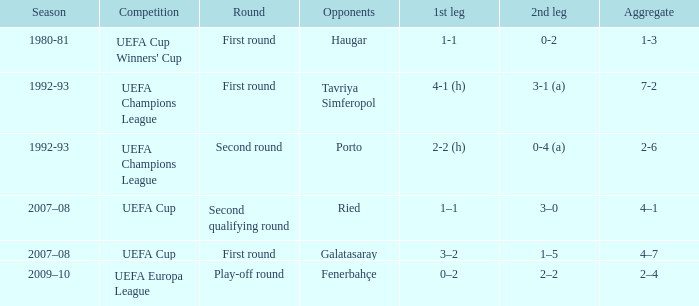For the first leg, when is galatasaray playing as the opposing team? 3–2. 